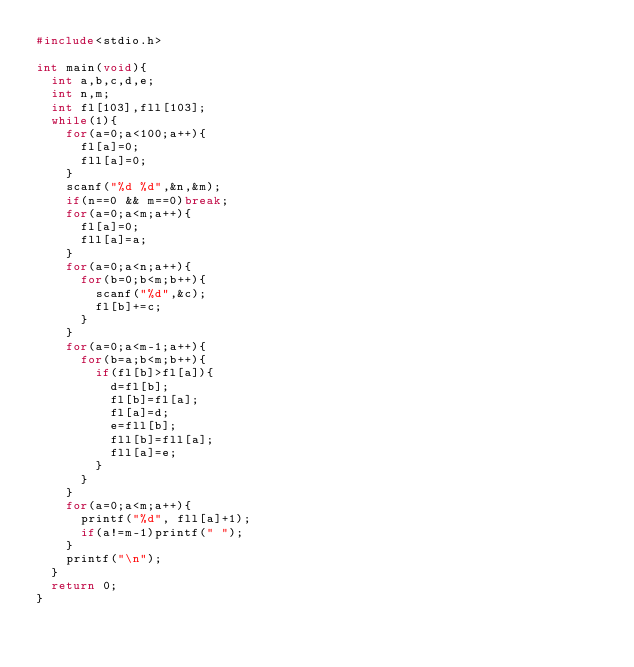Convert code to text. <code><loc_0><loc_0><loc_500><loc_500><_C_>#include<stdio.h> 

int main(void){
	int a,b,c,d,e;
	int n,m;
	int fl[103],fll[103];
	while(1){
		for(a=0;a<100;a++){
			fl[a]=0;
			fll[a]=0;
		}
		scanf("%d %d",&n,&m);
		if(n==0 && m==0)break;
		for(a=0;a<m;a++){
			fl[a]=0;
			fll[a]=a;
		}
		for(a=0;a<n;a++){
			for(b=0;b<m;b++){
				scanf("%d",&c);
				fl[b]+=c;
			}
		}
		for(a=0;a<m-1;a++){
			for(b=a;b<m;b++){
				if(fl[b]>fl[a]){
					d=fl[b];
					fl[b]=fl[a];
					fl[a]=d;
					e=fll[b];
					fll[b]=fll[a];
					fll[a]=e;
				}
			}
		}
		for(a=0;a<m;a++){
			printf("%d", fll[a]+1);
			if(a!=m-1)printf(" ");
		}		
		printf("\n");
	}
	return 0;	
}</code> 